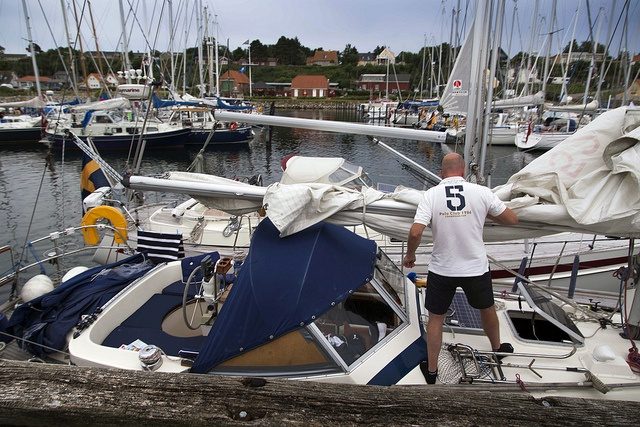Describe the objects in this image and their specific colors. I can see boat in darkgray, black, gray, and lightgray tones, people in darkgray, lightgray, black, and brown tones, boat in darkgray, black, gray, and lightgray tones, boat in darkgray, black, gray, and lightgray tones, and boat in darkgray, gray, lightgray, and black tones in this image. 